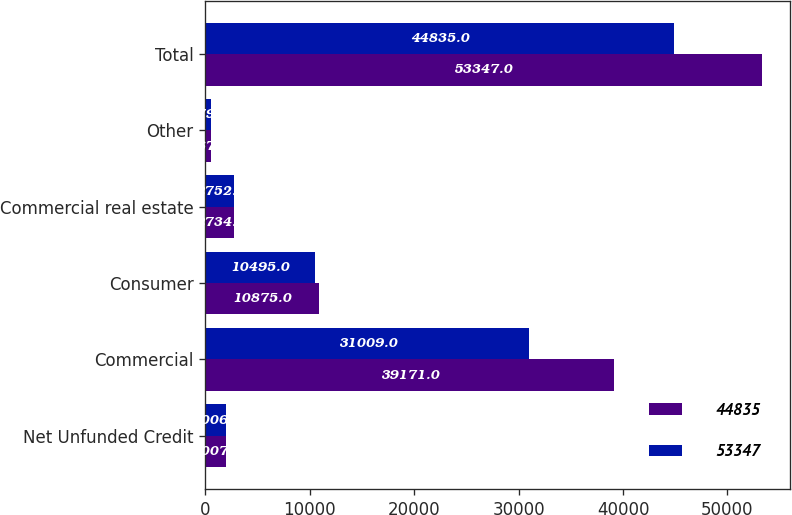<chart> <loc_0><loc_0><loc_500><loc_500><stacked_bar_chart><ecel><fcel>Net Unfunded Credit<fcel>Commercial<fcel>Consumer<fcel>Commercial real estate<fcel>Other<fcel>Total<nl><fcel>44835<fcel>2007<fcel>39171<fcel>10875<fcel>2734<fcel>567<fcel>53347<nl><fcel>53347<fcel>2006<fcel>31009<fcel>10495<fcel>2752<fcel>579<fcel>44835<nl></chart> 